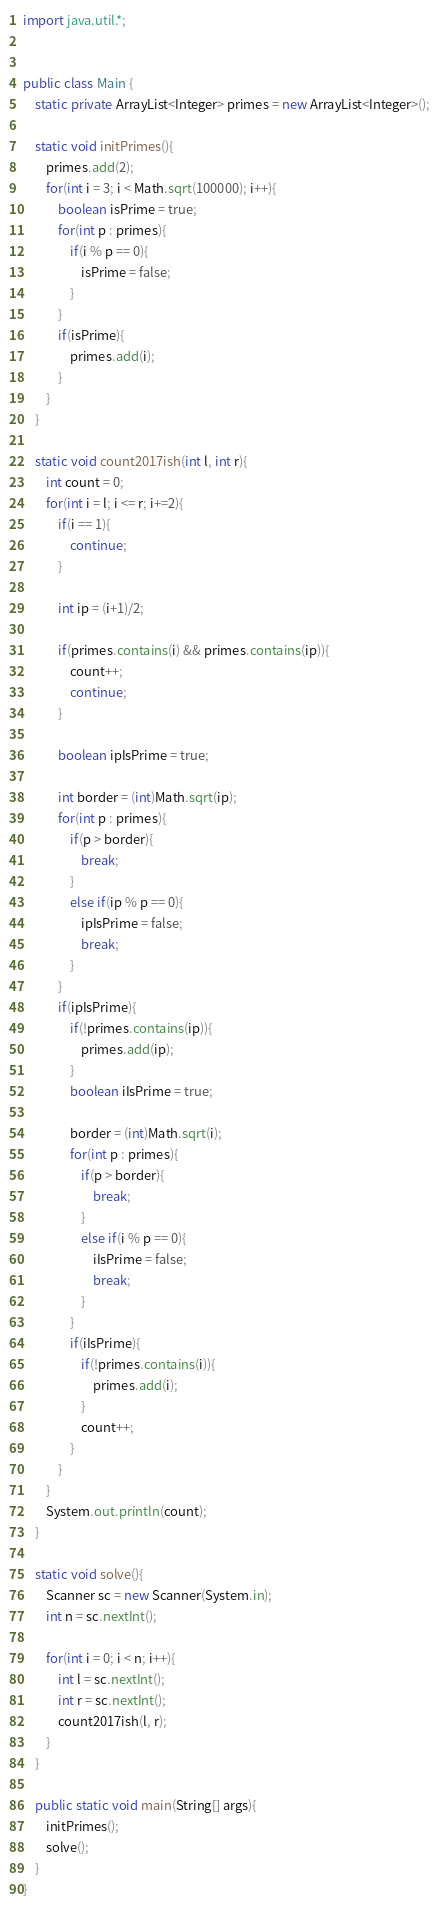Convert code to text. <code><loc_0><loc_0><loc_500><loc_500><_Java_>import java.util.*;


public class Main {
    static private ArrayList<Integer> primes = new ArrayList<Integer>();

    static void initPrimes(){
        primes.add(2);
        for(int i = 3; i < Math.sqrt(100000); i++){
            boolean isPrime = true;
            for(int p : primes){
                if(i % p == 0){
                    isPrime = false;
                }
            }
            if(isPrime){
                primes.add(i);
            }
        }
    }

    static void count2017ish(int l, int r){
        int count = 0;
        for(int i = l; i <= r; i+=2){
            if(i == 1){
                continue;
            }

            int ip = (i+1)/2;

            if(primes.contains(i) && primes.contains(ip)){
                count++;
                continue;
            }

            boolean ipIsPrime = true;

            int border = (int)Math.sqrt(ip);
            for(int p : primes){
                if(p > border){
                    break;
                }
                else if(ip % p == 0){
                    ipIsPrime = false;
                    break;
                }
            }
            if(ipIsPrime){
                if(!primes.contains(ip)){
                    primes.add(ip);
                }
                boolean iIsPrime = true;

                border = (int)Math.sqrt(i);
                for(int p : primes){
                    if(p > border){
                        break;
                    }
                    else if(i % p == 0){
                        iIsPrime = false;
                        break;
                    }
                }
                if(iIsPrime){
                    if(!primes.contains(i)){
                        primes.add(i);
                    }
                    count++;
                }
            }
        }
        System.out.println(count);
    }

    static void solve(){
        Scanner sc = new Scanner(System.in);
        int n = sc.nextInt();

        for(int i = 0; i < n; i++){
            int l = sc.nextInt();
            int r = sc.nextInt();
            count2017ish(l, r);
        }
    }

    public static void main(String[] args){
        initPrimes();
        solve();
    }
}</code> 